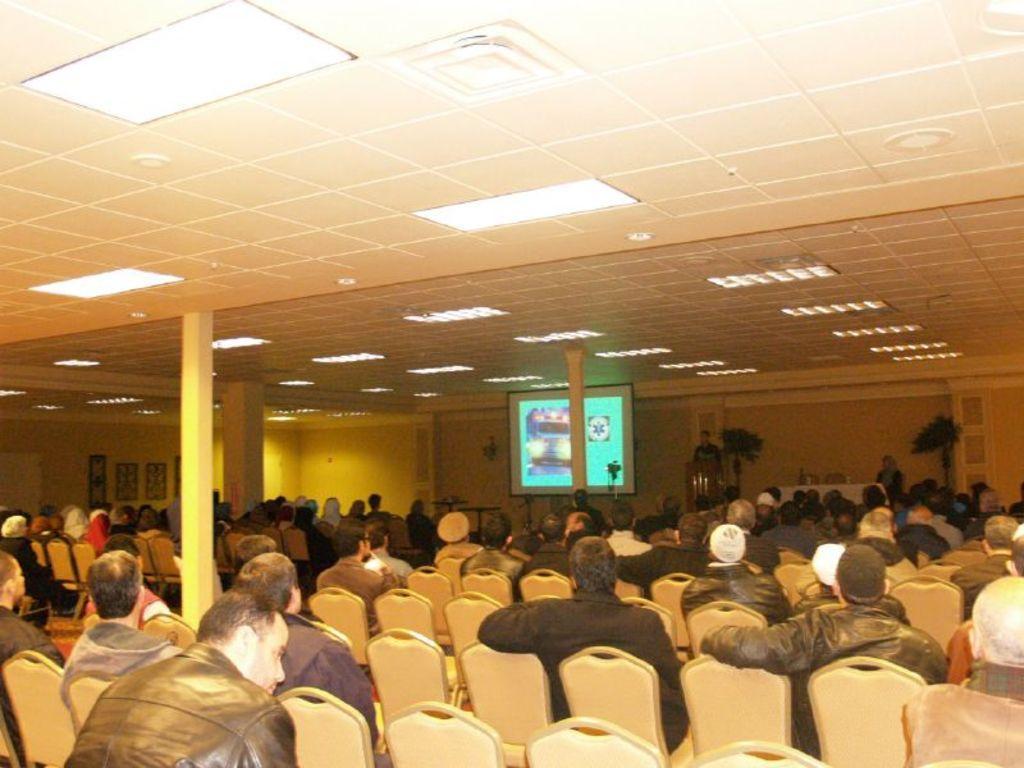How would you summarize this image in a sentence or two? In the image there are many people sitting on chairs staring in the front, there is a person standing on the stage in front of dias with plants on either side, there is a screen on the left side, there are lights over the ceiling. 